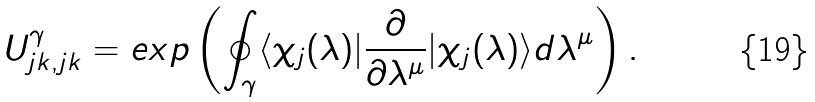Convert formula to latex. <formula><loc_0><loc_0><loc_500><loc_500>U ^ { \gamma } _ { j k , j k } = e x p \left ( \oint _ { \gamma } \langle \chi _ { j } ( \lambda ) | \frac { \partial } { \partial \lambda ^ { \mu } } | \chi _ { j } ( \lambda ) \rangle d \lambda ^ { \mu } \right ) .</formula> 